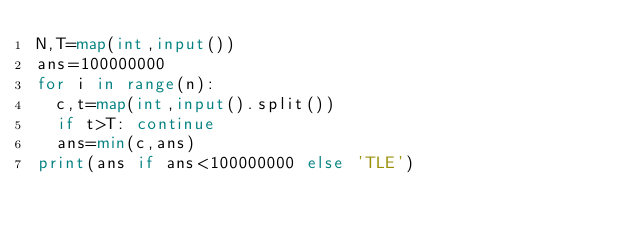Convert code to text. <code><loc_0><loc_0><loc_500><loc_500><_Python_>N,T=map(int,input())
ans=100000000
for i in range(n):
  c,t=map(int,input().split())
  if t>T: continue
  ans=min(c,ans)
print(ans if ans<100000000 else 'TLE')</code> 